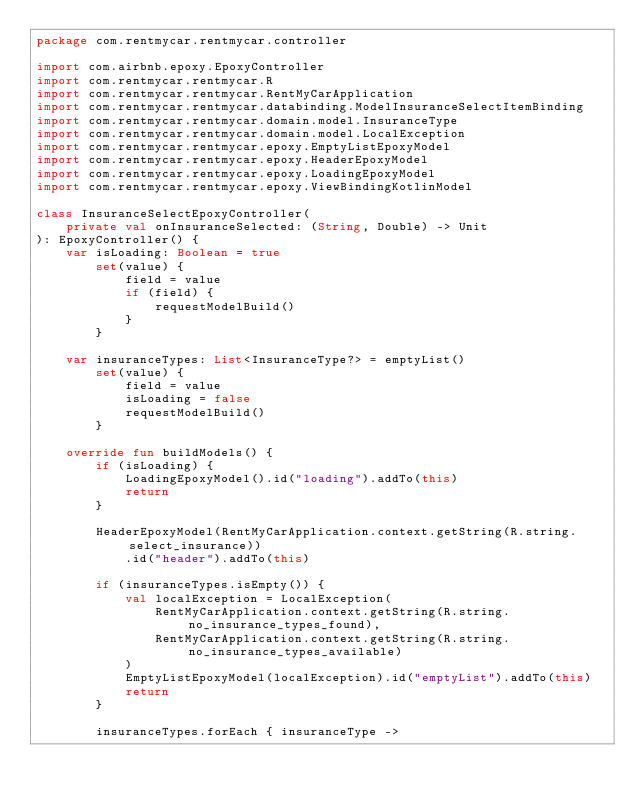Convert code to text. <code><loc_0><loc_0><loc_500><loc_500><_Kotlin_>package com.rentmycar.rentmycar.controller

import com.airbnb.epoxy.EpoxyController
import com.rentmycar.rentmycar.R
import com.rentmycar.rentmycar.RentMyCarApplication
import com.rentmycar.rentmycar.databinding.ModelInsuranceSelectItemBinding
import com.rentmycar.rentmycar.domain.model.InsuranceType
import com.rentmycar.rentmycar.domain.model.LocalException
import com.rentmycar.rentmycar.epoxy.EmptyListEpoxyModel
import com.rentmycar.rentmycar.epoxy.HeaderEpoxyModel
import com.rentmycar.rentmycar.epoxy.LoadingEpoxyModel
import com.rentmycar.rentmycar.epoxy.ViewBindingKotlinModel

class InsuranceSelectEpoxyController(
    private val onInsuranceSelected: (String, Double) -> Unit
): EpoxyController() {
    var isLoading: Boolean = true
        set(value) {
            field = value
            if (field) {
                requestModelBuild()
            }
        }

    var insuranceTypes: List<InsuranceType?> = emptyList()
        set(value) {
            field = value
            isLoading = false
            requestModelBuild()
        }

    override fun buildModels() {
        if (isLoading) {
            LoadingEpoxyModel().id("loading").addTo(this)
            return
        }

        HeaderEpoxyModel(RentMyCarApplication.context.getString(R.string.select_insurance))
            .id("header").addTo(this)

        if (insuranceTypes.isEmpty()) {
            val localException = LocalException(
                RentMyCarApplication.context.getString(R.string.no_insurance_types_found),
                RentMyCarApplication.context.getString(R.string.no_insurance_types_available)
            )
            EmptyListEpoxyModel(localException).id("emptyList").addTo(this)
            return
        }

        insuranceTypes.forEach { insuranceType -></code> 